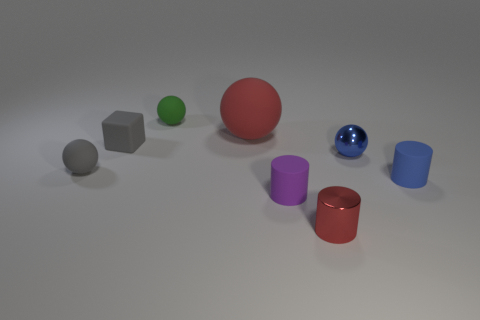Add 1 blue rubber cylinders. How many objects exist? 9 Subtract all cubes. How many objects are left? 7 Subtract all tiny green rubber spheres. Subtract all red things. How many objects are left? 5 Add 3 tiny blue rubber things. How many tiny blue rubber things are left? 4 Add 8 big blue rubber spheres. How many big blue rubber spheres exist? 8 Subtract 0 yellow cylinders. How many objects are left? 8 